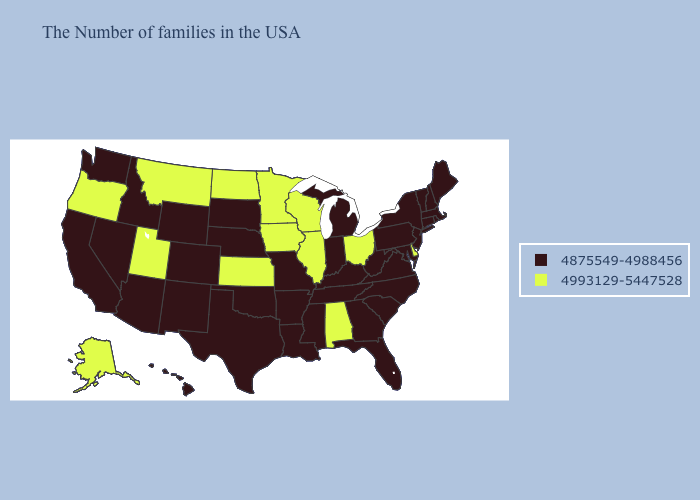What is the value of Oregon?
Give a very brief answer. 4993129-5447528. Does Virginia have the lowest value in the South?
Concise answer only. Yes. Does Hawaii have a higher value than Indiana?
Quick response, please. No. Name the states that have a value in the range 4875549-4988456?
Write a very short answer. Maine, Massachusetts, Rhode Island, New Hampshire, Vermont, Connecticut, New York, New Jersey, Maryland, Pennsylvania, Virginia, North Carolina, South Carolina, West Virginia, Florida, Georgia, Michigan, Kentucky, Indiana, Tennessee, Mississippi, Louisiana, Missouri, Arkansas, Nebraska, Oklahoma, Texas, South Dakota, Wyoming, Colorado, New Mexico, Arizona, Idaho, Nevada, California, Washington, Hawaii. What is the highest value in states that border Illinois?
Write a very short answer. 4993129-5447528. What is the value of Vermont?
Concise answer only. 4875549-4988456. How many symbols are there in the legend?
Answer briefly. 2. Name the states that have a value in the range 4993129-5447528?
Short answer required. Delaware, Ohio, Alabama, Wisconsin, Illinois, Minnesota, Iowa, Kansas, North Dakota, Utah, Montana, Oregon, Alaska. Does Montana have the highest value in the USA?
Be succinct. Yes. Which states have the highest value in the USA?
Quick response, please. Delaware, Ohio, Alabama, Wisconsin, Illinois, Minnesota, Iowa, Kansas, North Dakota, Utah, Montana, Oregon, Alaska. Does the first symbol in the legend represent the smallest category?
Write a very short answer. Yes. Name the states that have a value in the range 4875549-4988456?
Write a very short answer. Maine, Massachusetts, Rhode Island, New Hampshire, Vermont, Connecticut, New York, New Jersey, Maryland, Pennsylvania, Virginia, North Carolina, South Carolina, West Virginia, Florida, Georgia, Michigan, Kentucky, Indiana, Tennessee, Mississippi, Louisiana, Missouri, Arkansas, Nebraska, Oklahoma, Texas, South Dakota, Wyoming, Colorado, New Mexico, Arizona, Idaho, Nevada, California, Washington, Hawaii. Which states have the lowest value in the South?
Write a very short answer. Maryland, Virginia, North Carolina, South Carolina, West Virginia, Florida, Georgia, Kentucky, Tennessee, Mississippi, Louisiana, Arkansas, Oklahoma, Texas. 